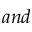<formula> <loc_0><loc_0><loc_500><loc_500>a n d</formula> 